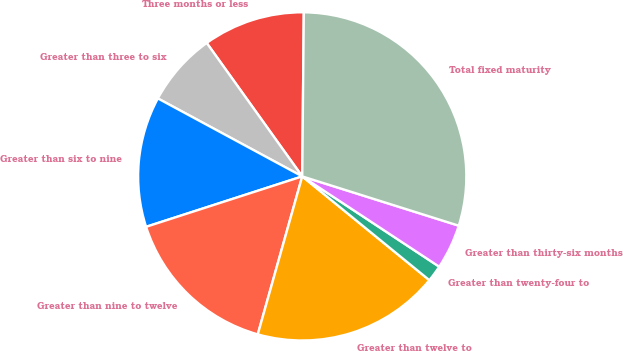Convert chart to OTSL. <chart><loc_0><loc_0><loc_500><loc_500><pie_chart><fcel>Three months or less<fcel>Greater than three to six<fcel>Greater than six to nine<fcel>Greater than nine to twelve<fcel>Greater than twelve to<fcel>Greater than twenty-four to<fcel>Greater than thirty-six months<fcel>Total fixed maturity<nl><fcel>10.04%<fcel>7.23%<fcel>12.85%<fcel>15.66%<fcel>18.47%<fcel>1.62%<fcel>4.42%<fcel>29.7%<nl></chart> 